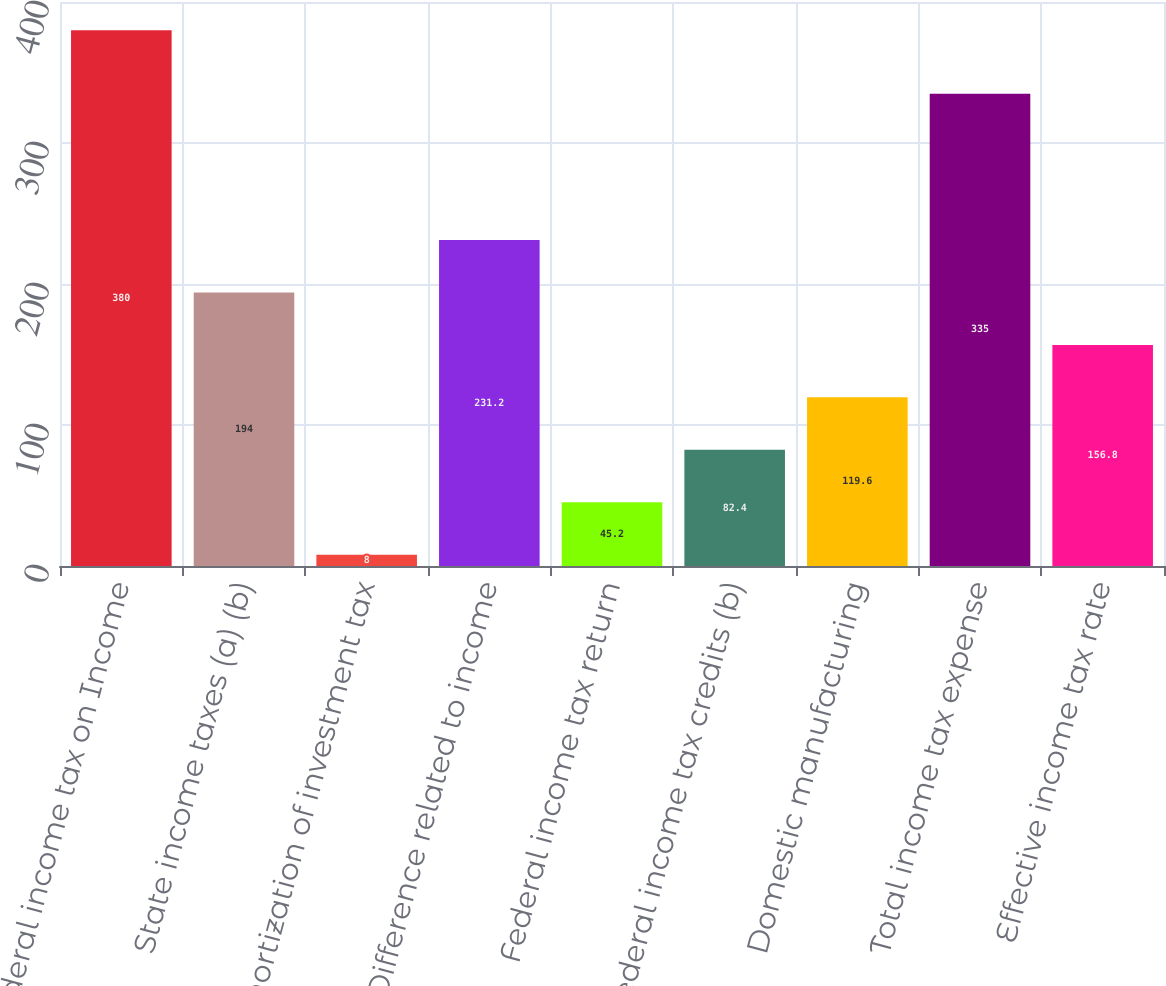Convert chart to OTSL. <chart><loc_0><loc_0><loc_500><loc_500><bar_chart><fcel>Federal income tax on Income<fcel>State income taxes (a) (b)<fcel>Amortization of investment tax<fcel>Difference related to income<fcel>Federal income tax return<fcel>Federal income tax credits (b)<fcel>Domestic manufacturing<fcel>Total income tax expense<fcel>Effective income tax rate<nl><fcel>380<fcel>194<fcel>8<fcel>231.2<fcel>45.2<fcel>82.4<fcel>119.6<fcel>335<fcel>156.8<nl></chart> 